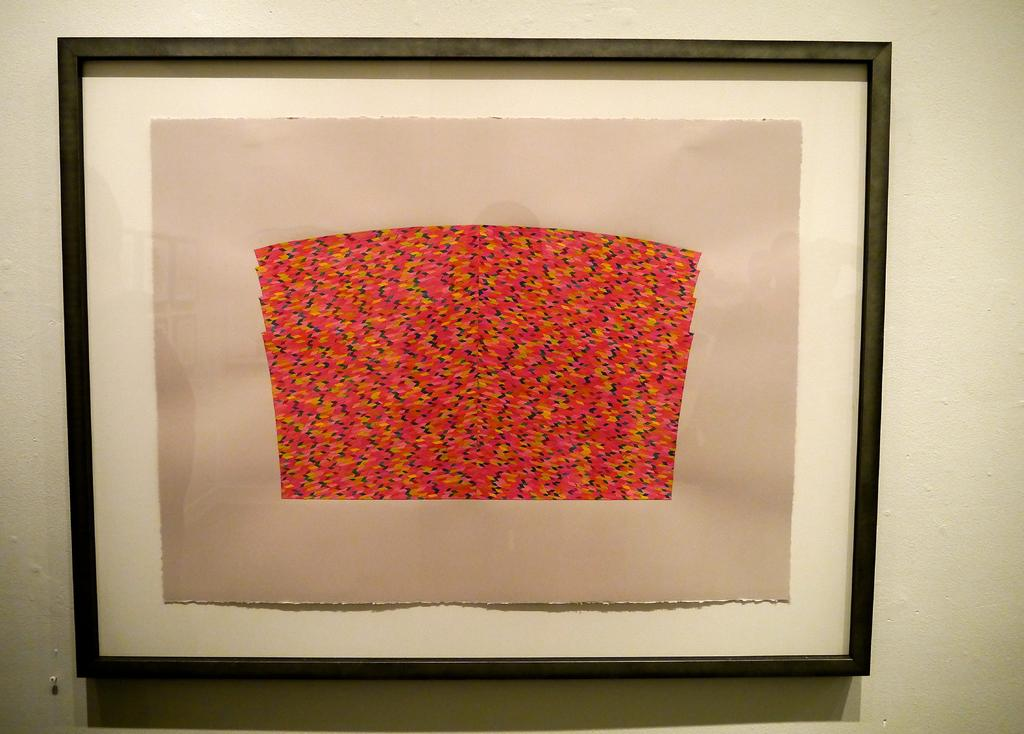What is attached to the wall in the image? There is a frame in the image that is attached to the wall. What is inside the frame? There is a piece of paper in the frame. What can be seen on the piece of paper? The piece of paper has a design on it. Can you describe the wall where the frame is attached? This is a wall where the frame is attached. What is the tax rate for the design on the piece of paper in the image? There is no mention of tax or tax rates in the image, as it features a frame with a piece of paper containing a design. 